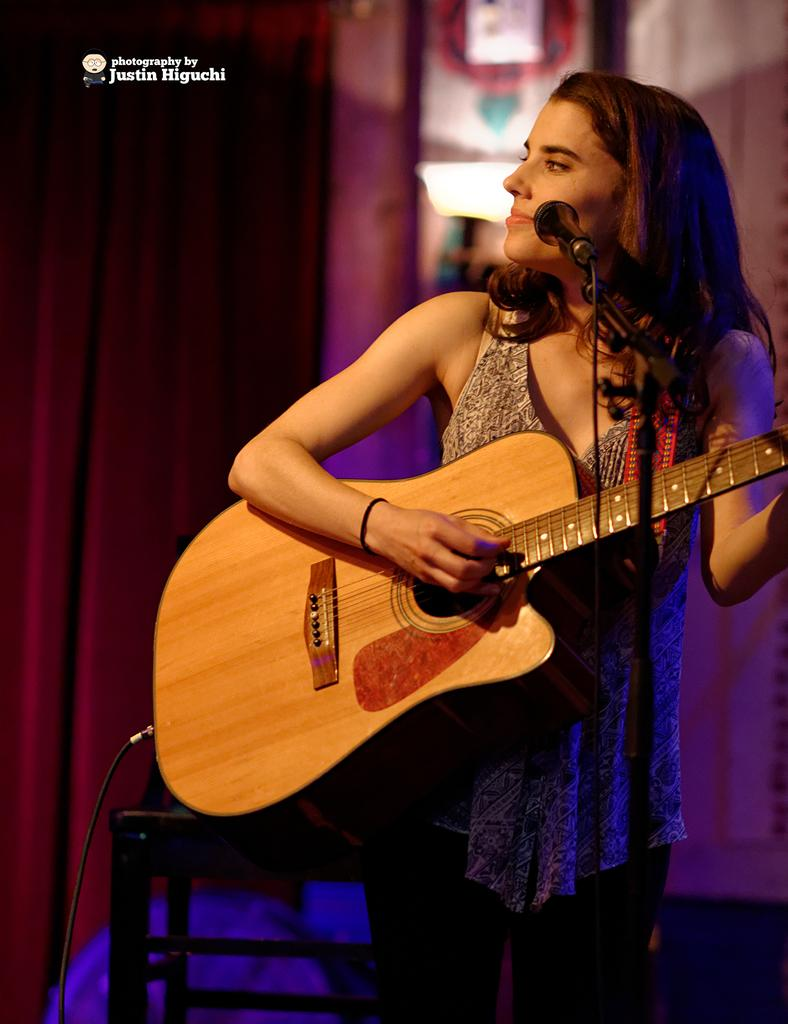Who is the main subject in the image? There is a woman in the image. What is the woman holding in the image? The woman is holding a guitar. What is the woman doing with the guitar? The woman is playing the guitar. What is in front of the woman? There is a microphone in front of the woman. What can be seen in the background of the image? There are curtains visible in the background, and the background is blurry. Can you tell me how many sons the woman has in the image? There is no information about the woman's sons in the image, so it cannot be determined. What attempt is the woman making in the image? There is no indication of an attempt or any specific action being made by the woman in the image, other than playing the guitar. 